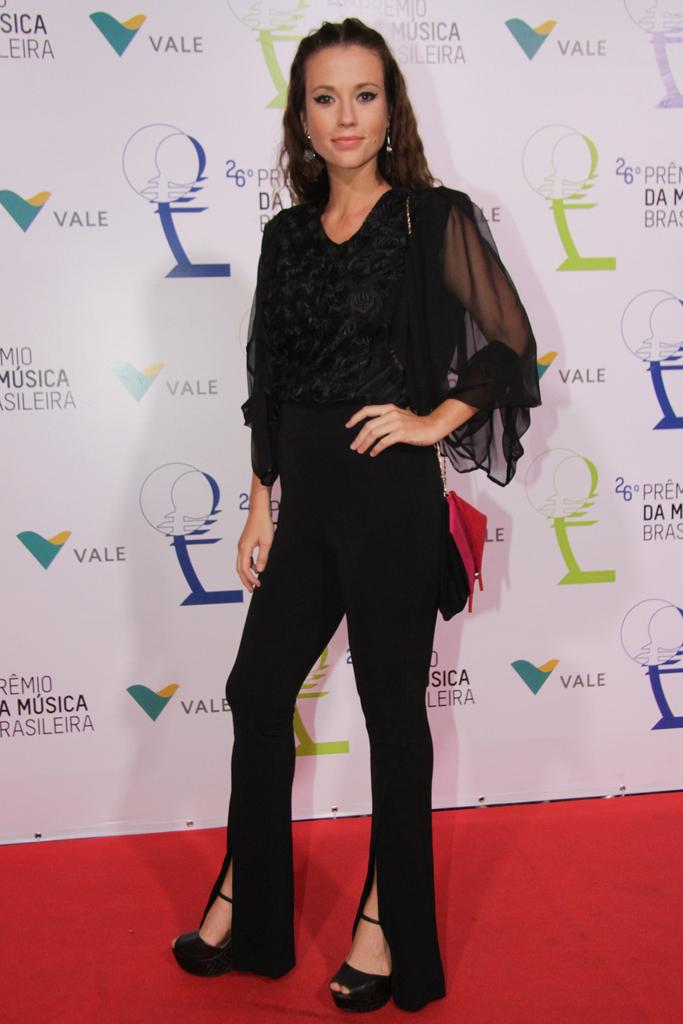Who is present in the image? There is a woman in the image. What is the woman doing in the image? The woman is standing in the image. What type of footwear is the woman wearing? The woman is wearing sandals. What accessories is the woman wearing? The woman is wearing earrings. What is the woman's facial expression in the image? The woman is smiling in the image. What is the color of the carpet in the image? The carpet in the image is red. What is in the background of the image? There is a poster in the background of the image. What is written on the poster in the image? There is text on the poster in the image. What type of shirt is the woman exchanging with the man in the image? There is no man present in the image, and the woman is not exchanging any shirt. 